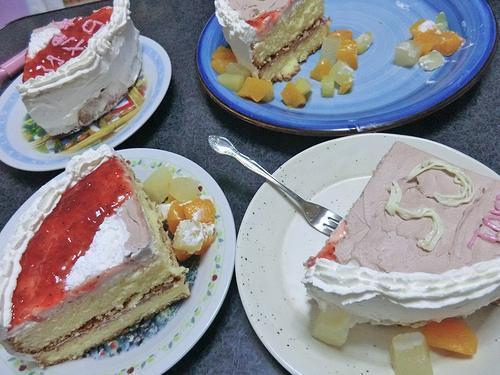How many plates of food are visible?
Give a very brief answer. 4. How many forks are visible?
Give a very brief answer. 1. 